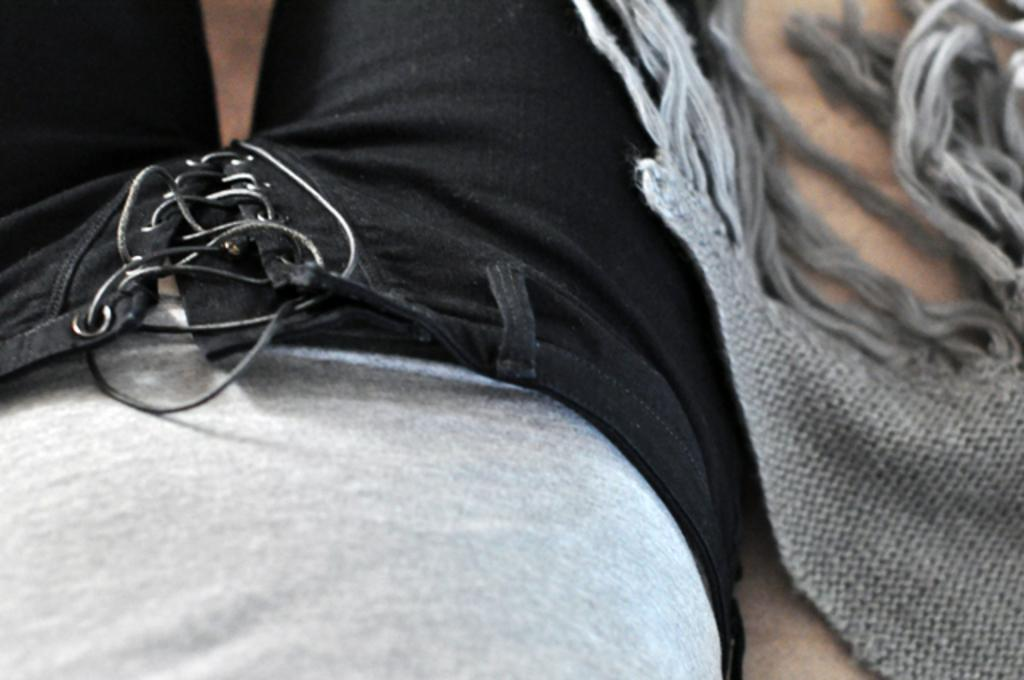Who or what is on the left side of the image? There is a person on the left side of the image. What can be seen on the right side of the image? There is a cloth on the right side of the image. What color is the person's lip in the image? There is no information about the person's lip color in the image. What time of day is depicted in the image? The provided facts do not mention the time of day, so it cannot be determined from the image. 